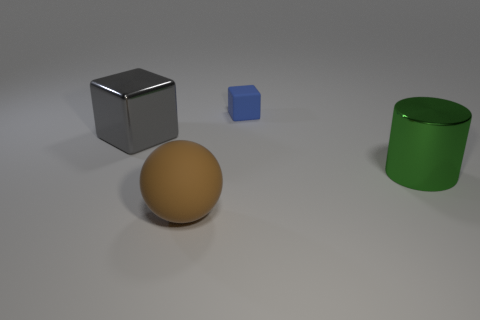Add 1 small blue rubber cubes. How many objects exist? 5 Subtract all spheres. How many objects are left? 3 Subtract all blue matte objects. Subtract all spheres. How many objects are left? 2 Add 3 gray shiny cubes. How many gray shiny cubes are left? 4 Add 3 big rubber objects. How many big rubber objects exist? 4 Subtract 0 green blocks. How many objects are left? 4 